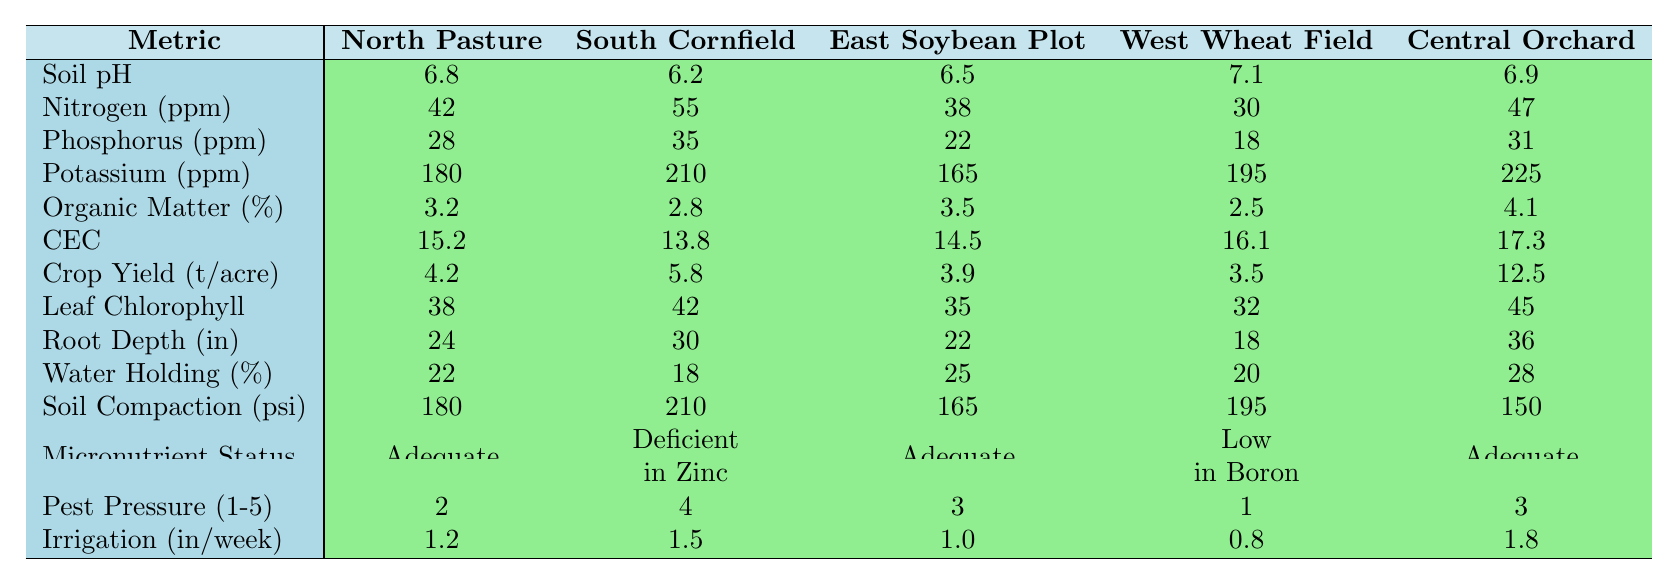What is the soil pH level in the South Cornfield? The table lists the soil pH for each field. For the South Cornfield, the value is explicitly stated as 6.2.
Answer: 6.2 Which field has the highest potassium level? By comparing the potassium values across all fields, the highest value of 225 ppm is found in the Central Orchard.
Answer: Central Orchard What is the difference in crop yield between the East Soybean Plot and the West Wheat Field? The crop yield for the East Soybean Plot is 3.9 tons per acre, while for the West Wheat Field it is 3.5 tons per acre. The difference is calculated as 3.9 - 3.5 = 0.4 tons per acre.
Answer: 0.4 tons per acre Is the nitrogen level in the North Pasture adequate compared to the West Wheat Field? The nitrogen level in the North Pasture is 42 ppm and in the West Wheat Field it is 30 ppm. Since 42 ppm is greater than 30 ppm, the nitrogen level in the North Pasture is considered adequate by comparison.
Answer: Yes What is the average leaf chlorophyll content across all fields? The leaf chlorophyll values are 38, 42, 35, 32, and 45. Adding these values gives 38 + 42 + 35 + 32 + 45 = 192. Dividing by the number of fields, 192 / 5 = 38.4.
Answer: 38.4 In which field is the soil micronutrient status deficient? The table mentions that the South Cornfield has a micronutrient status marked as "Deficient in Zinc."
Answer: South Cornfield How much more irrigation is required in Central Orchard compared to West Wheat Field? The irrigation requirement in Central Orchard is 1.8 inches per week and in West Wheat Field is 0.8 inches. The difference is 1.8 - 0.8 = 1.0 inches.
Answer: 1.0 inch Which field has the lowest soil compaction pressure? Soil compaction measurements are listed as 180, 210, 165, 195, and 150 psi. The lowest measurement is 150 psi, which corresponds to the Central Orchard.
Answer: Central Orchard If we sum the nitrogen and phosphorus levels in the East Soybean Plot, what is the result? The nitrogen level for the East Soybean Plot is 38 ppm and the phosphorus level is 22 ppm. Adding these gives 38 + 22 = 60 ppm.
Answer: 60 ppm Based on the data, does higher cation exchange capacity correlate with higher crop yield? By analyzing the data, the Central Orchard has the highest cation exchange capacity of 17.3 and the highest crop yield of 12.5 tons per acre. Lower values like the West Wheat Field (16.1 CEC, 3.5 yield) and their respective yields suggest varying correlations. However, noting only two data points with a clear upward trend may be inconclusive.
Answer: Indeterminate 